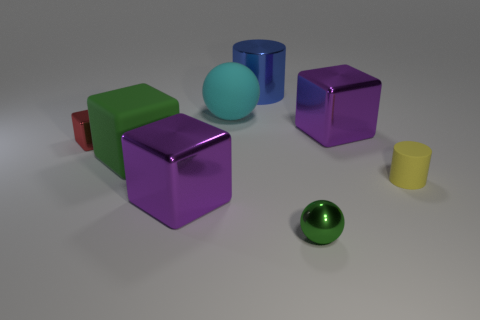Do the metallic sphere and the big rubber cube have the same color?
Your answer should be very brief. Yes. How many things are big purple metallic objects or tiny green metallic objects?
Offer a terse response. 3. There is a red shiny object that is the same shape as the big green rubber thing; what size is it?
Make the answer very short. Small. What number of other objects are there of the same color as the big rubber block?
Your answer should be compact. 1. How many cylinders are yellow objects or big shiny objects?
Offer a terse response. 2. There is a small metal thing behind the small ball in front of the large matte ball; what color is it?
Offer a terse response. Red. The green rubber thing has what shape?
Offer a terse response. Cube. There is a block on the right side of the rubber sphere; is it the same size as the matte cylinder?
Provide a short and direct response. No. Are there any tiny yellow cylinders that have the same material as the green block?
Offer a very short reply. Yes. What number of things are matte cubes to the right of the tiny red shiny block or blue matte cubes?
Provide a short and direct response. 1. 